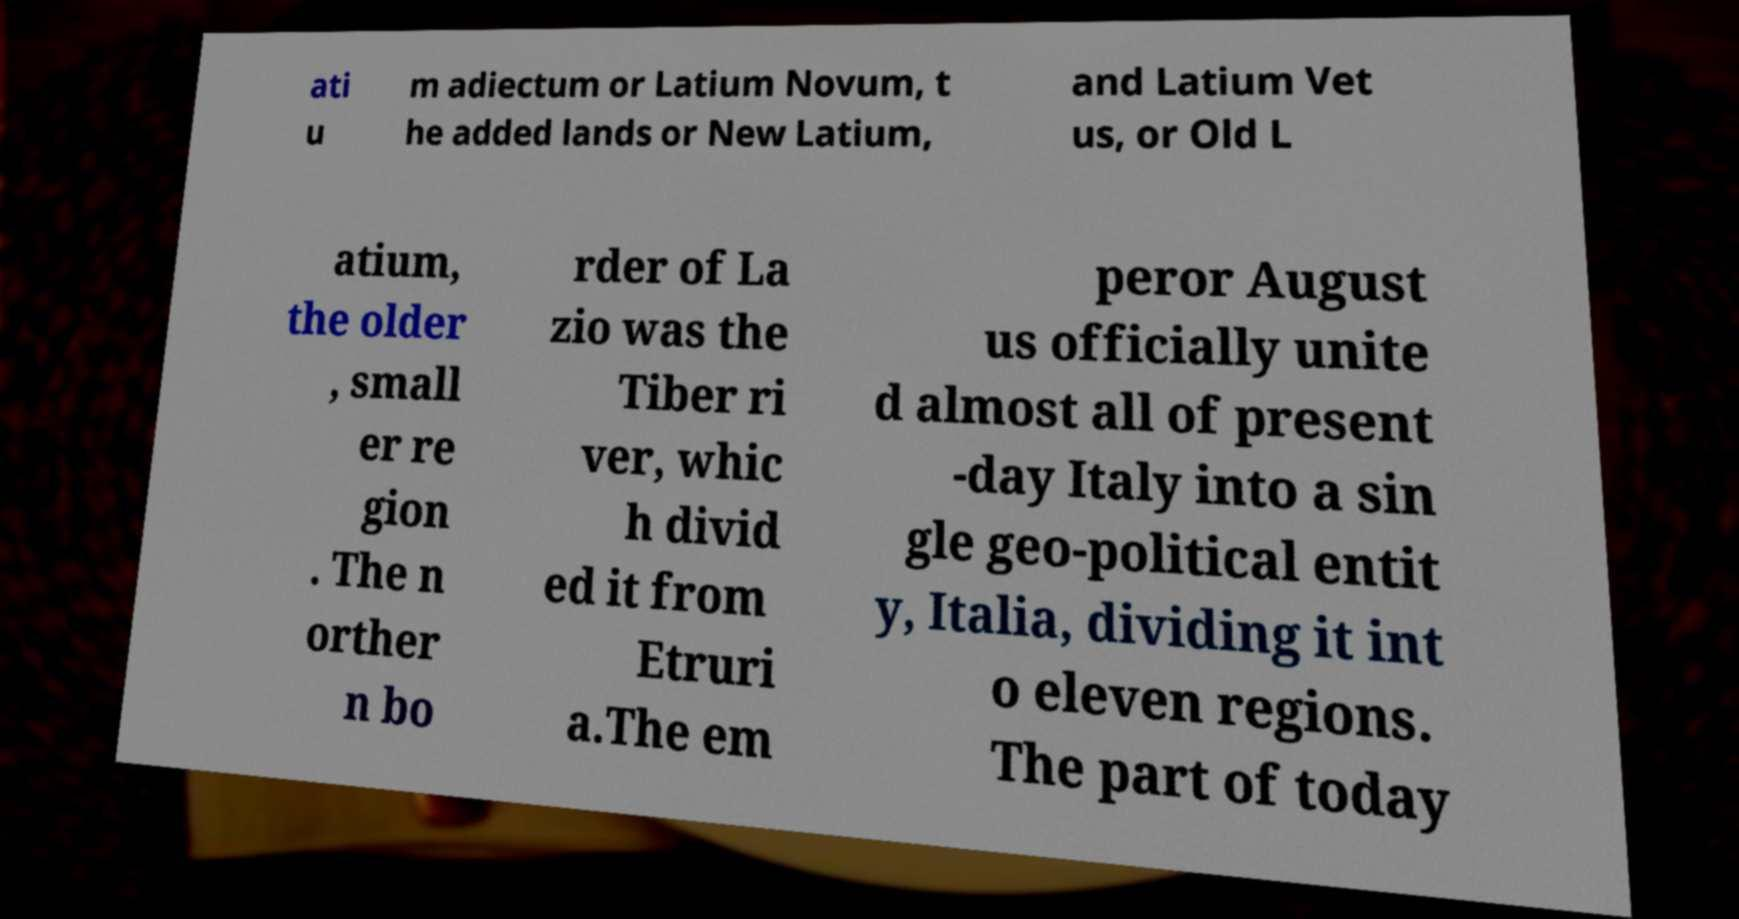Could you assist in decoding the text presented in this image and type it out clearly? ati u m adiectum or Latium Novum, t he added lands or New Latium, and Latium Vet us, or Old L atium, the older , small er re gion . The n orther n bo rder of La zio was the Tiber ri ver, whic h divid ed it from Etruri a.The em peror August us officially unite d almost all of present -day Italy into a sin gle geo-political entit y, Italia, dividing it int o eleven regions. The part of today 